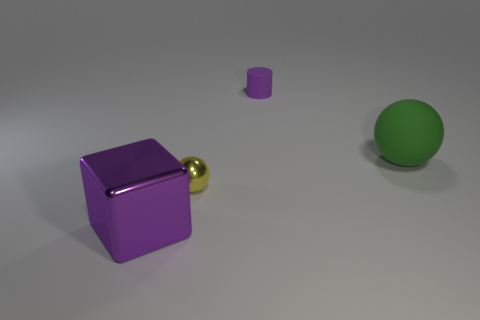What is the shape of the tiny matte thing that is the same color as the big cube?
Keep it short and to the point. Cylinder. There is a object that is in front of the rubber cylinder and behind the tiny metal sphere; how big is it?
Provide a short and direct response. Large. Are there any yellow metal balls that have the same size as the purple cylinder?
Your response must be concise. Yes. Is the number of balls behind the yellow metallic object greater than the number of small cylinders that are behind the small purple matte cylinder?
Make the answer very short. Yes. Is the small sphere made of the same material as the purple thing that is left of the small cylinder?
Your answer should be very brief. Yes. How many small things are on the left side of the ball on the left side of the thing right of the cylinder?
Your answer should be compact. 0. There is a green object; is it the same shape as the purple object in front of the tiny metallic thing?
Offer a terse response. No. What color is the object that is both in front of the purple rubber cylinder and behind the tiny metal object?
Your response must be concise. Green. What material is the purple object that is behind the tiny thing in front of the purple object that is right of the large shiny cube made of?
Your response must be concise. Rubber. What is the material of the yellow ball?
Your answer should be very brief. Metal. 